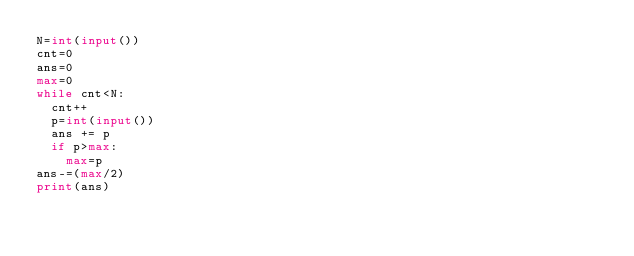<code> <loc_0><loc_0><loc_500><loc_500><_Python_>N=int(input())
cnt=0
ans=0
max=0
while cnt<N:
  cnt++
  p=int(input())
  ans += p
  if p>max:
    max=p
ans-=(max/2)
print(ans)</code> 